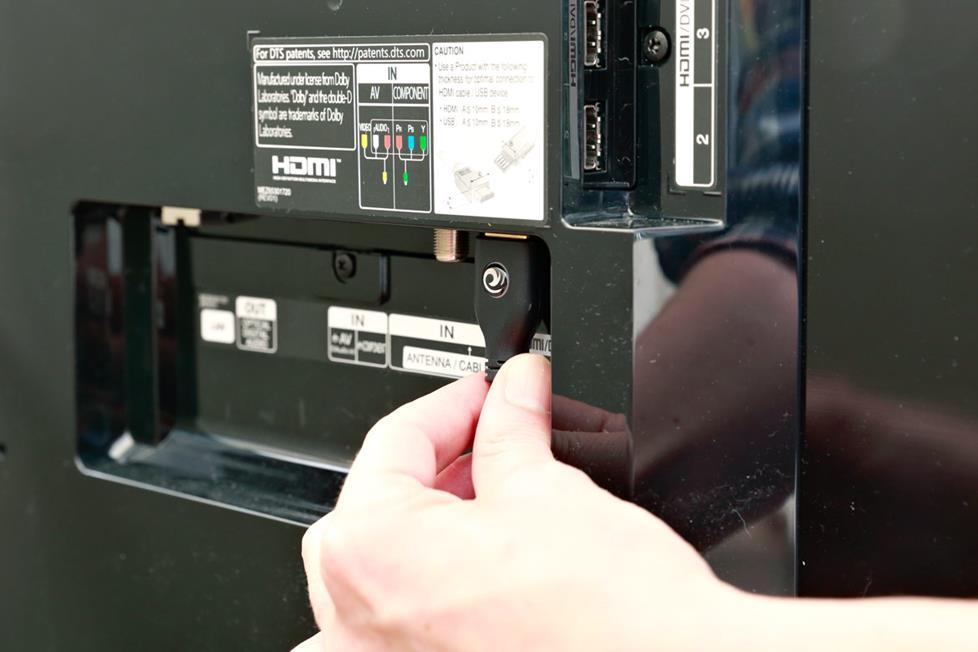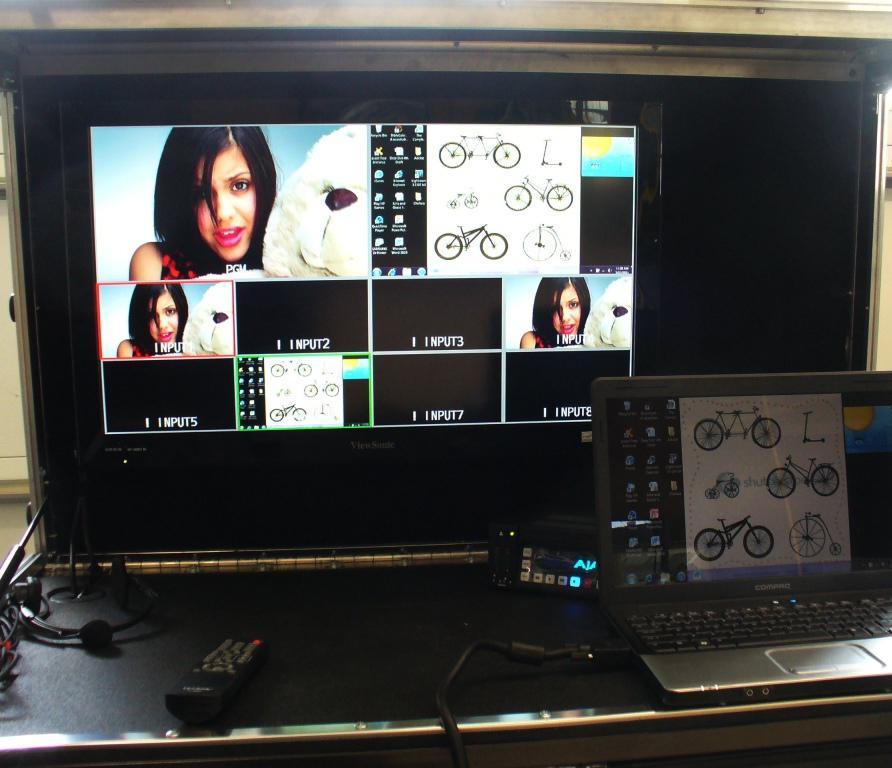The first image is the image on the left, the second image is the image on the right. Given the left and right images, does the statement "The right image contains  television with an antenna." hold true? Answer yes or no. No. The first image is the image on the left, the second image is the image on the right. Considering the images on both sides, is "The right image shows one pale-colored device with an antenna angled leftward and a grid of dots on its front." valid? Answer yes or no. No. 